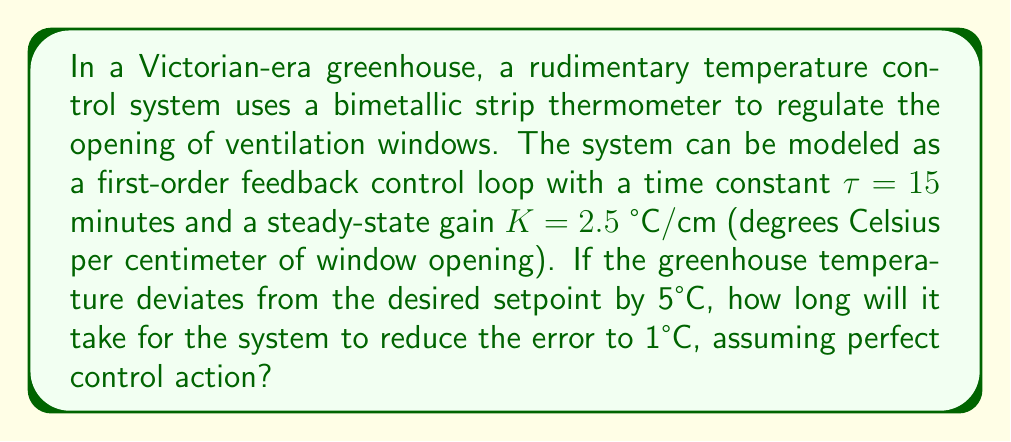What is the answer to this math problem? To solve this problem, we need to use the first-order system response equation and the concept of time constant. Let's approach this step-by-step:

1) The first-order system response is given by:

   $$e(t) = e_0 e^{-t/\tau}$$

   Where:
   $e(t)$ is the error at time $t$
   $e_0$ is the initial error
   $\tau$ is the time constant
   $t$ is the time

2) We are given:
   $e_0 = 5°C$ (initial error)
   $e(t) = 1°C$ (final error we want to reach)
   $\tau = 15$ minutes

3) Substituting these values into the equation:

   $$1 = 5 e^{-t/15}$$

4) Solving for $t$:

   $$\frac{1}{5} = e^{-t/15}$$

   $$\ln(\frac{1}{5}) = -\frac{t}{15}$$

   $$-\ln(5) = -\frac{t}{15}$$

   $$t = 15 \ln(5)$$

5) Calculate the result:

   $$t = 15 \times 1.6094 = 24.14 \text{ minutes}$$

This time represents how long it will take for the greenhouse temperature to come within 1°C of the setpoint, given the characteristics of the control system.
Answer: $24.14$ minutes 